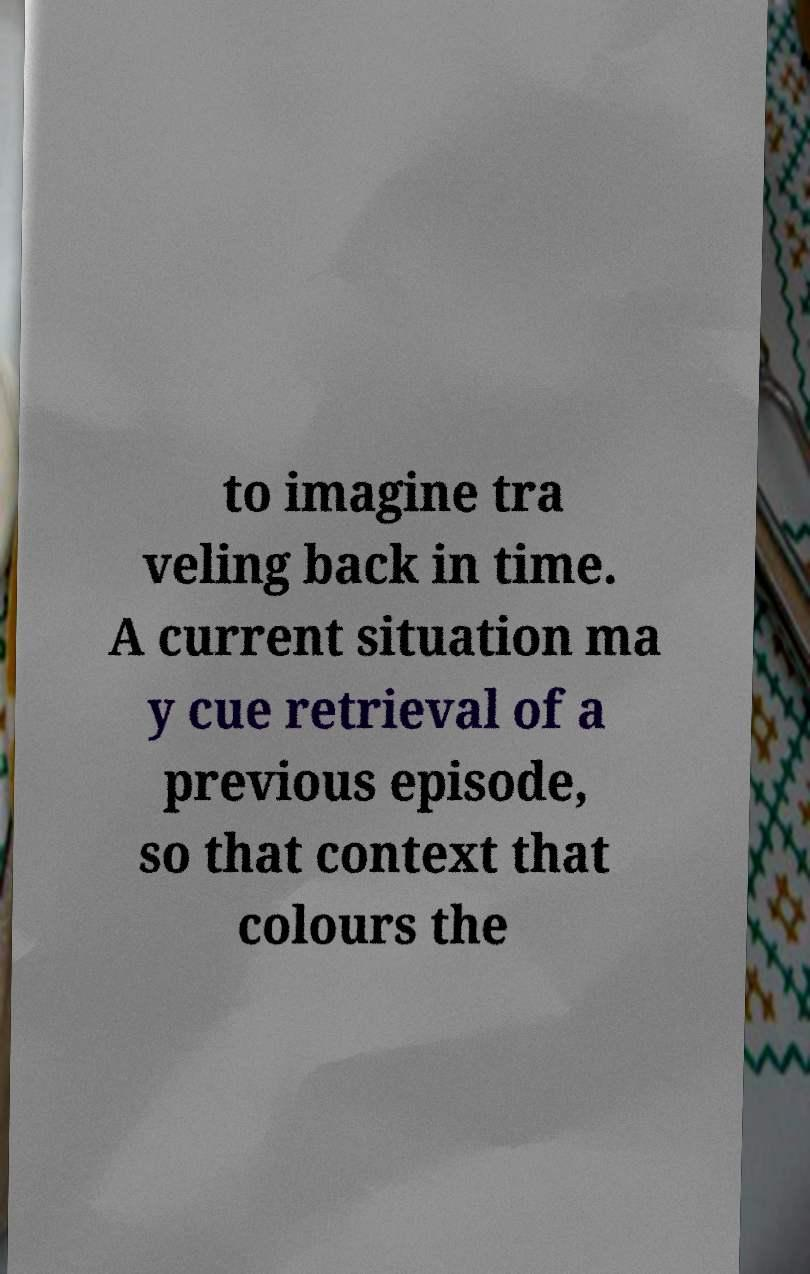I need the written content from this picture converted into text. Can you do that? to imagine tra veling back in time. A current situation ma y cue retrieval of a previous episode, so that context that colours the 